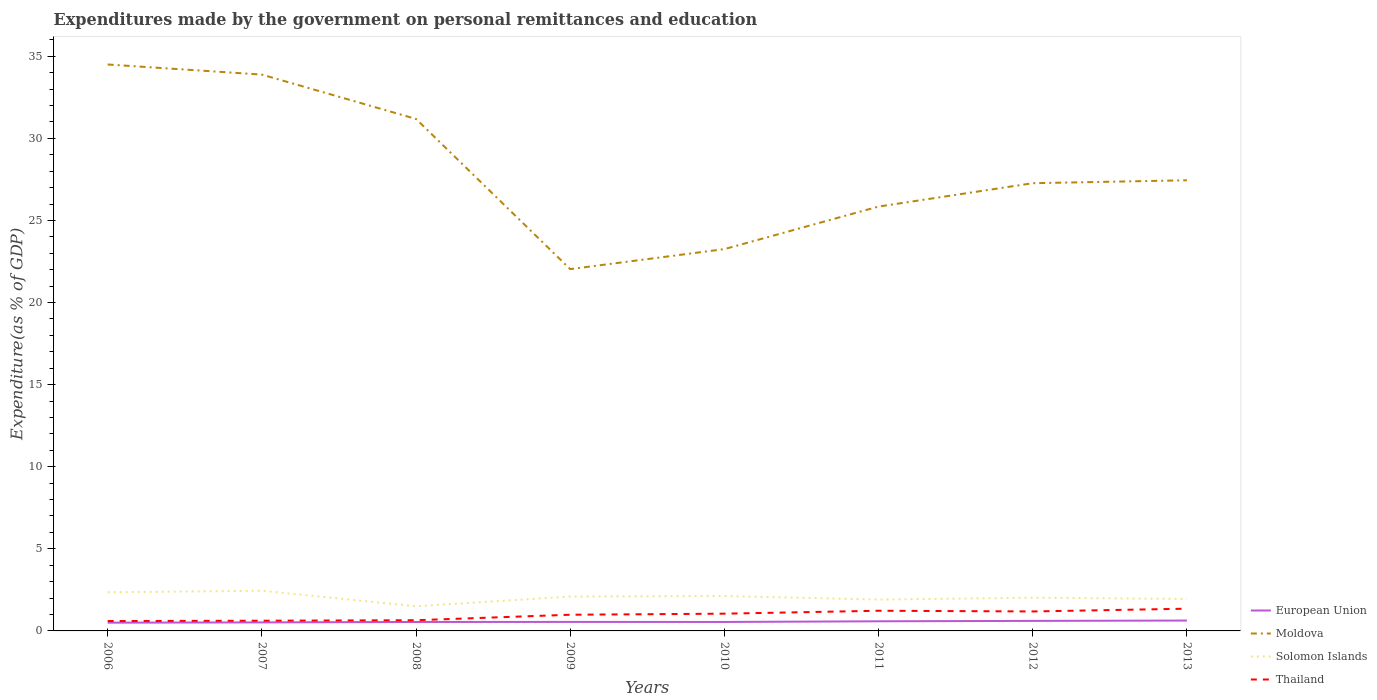Is the number of lines equal to the number of legend labels?
Keep it short and to the point. Yes. Across all years, what is the maximum expenditures made by the government on personal remittances and education in European Union?
Make the answer very short. 0.5. In which year was the expenditures made by the government on personal remittances and education in European Union maximum?
Your response must be concise. 2006. What is the total expenditures made by the government on personal remittances and education in Moldova in the graph?
Provide a short and direct response. 11.25. What is the difference between the highest and the second highest expenditures made by the government on personal remittances and education in Thailand?
Your answer should be very brief. 0.75. What is the difference between the highest and the lowest expenditures made by the government on personal remittances and education in Moldova?
Ensure brevity in your answer.  3. Is the expenditures made by the government on personal remittances and education in Thailand strictly greater than the expenditures made by the government on personal remittances and education in Moldova over the years?
Ensure brevity in your answer.  Yes. How many lines are there?
Provide a succinct answer. 4. How many years are there in the graph?
Offer a terse response. 8. What is the title of the graph?
Ensure brevity in your answer.  Expenditures made by the government on personal remittances and education. Does "Myanmar" appear as one of the legend labels in the graph?
Your response must be concise. No. What is the label or title of the Y-axis?
Offer a terse response. Expenditure(as % of GDP). What is the Expenditure(as % of GDP) in European Union in 2006?
Your response must be concise. 0.5. What is the Expenditure(as % of GDP) of Moldova in 2006?
Ensure brevity in your answer.  34.5. What is the Expenditure(as % of GDP) of Solomon Islands in 2006?
Ensure brevity in your answer.  2.35. What is the Expenditure(as % of GDP) in Thailand in 2006?
Make the answer very short. 0.6. What is the Expenditure(as % of GDP) of European Union in 2007?
Your answer should be compact. 0.52. What is the Expenditure(as % of GDP) of Moldova in 2007?
Provide a succinct answer. 33.88. What is the Expenditure(as % of GDP) in Solomon Islands in 2007?
Make the answer very short. 2.45. What is the Expenditure(as % of GDP) of Thailand in 2007?
Offer a very short reply. 0.62. What is the Expenditure(as % of GDP) in European Union in 2008?
Give a very brief answer. 0.55. What is the Expenditure(as % of GDP) in Moldova in 2008?
Make the answer very short. 31.18. What is the Expenditure(as % of GDP) of Solomon Islands in 2008?
Make the answer very short. 1.5. What is the Expenditure(as % of GDP) in Thailand in 2008?
Your answer should be very brief. 0.65. What is the Expenditure(as % of GDP) in European Union in 2009?
Offer a very short reply. 0.55. What is the Expenditure(as % of GDP) in Moldova in 2009?
Provide a succinct answer. 22.04. What is the Expenditure(as % of GDP) in Solomon Islands in 2009?
Provide a succinct answer. 2.09. What is the Expenditure(as % of GDP) in Thailand in 2009?
Provide a short and direct response. 0.99. What is the Expenditure(as % of GDP) in European Union in 2010?
Keep it short and to the point. 0.55. What is the Expenditure(as % of GDP) of Moldova in 2010?
Make the answer very short. 23.25. What is the Expenditure(as % of GDP) in Solomon Islands in 2010?
Offer a very short reply. 2.13. What is the Expenditure(as % of GDP) in Thailand in 2010?
Provide a short and direct response. 1.05. What is the Expenditure(as % of GDP) in European Union in 2011?
Keep it short and to the point. 0.59. What is the Expenditure(as % of GDP) in Moldova in 2011?
Provide a short and direct response. 25.85. What is the Expenditure(as % of GDP) of Solomon Islands in 2011?
Your response must be concise. 1.91. What is the Expenditure(as % of GDP) of Thailand in 2011?
Offer a very short reply. 1.23. What is the Expenditure(as % of GDP) in European Union in 2012?
Ensure brevity in your answer.  0.61. What is the Expenditure(as % of GDP) in Moldova in 2012?
Ensure brevity in your answer.  27.27. What is the Expenditure(as % of GDP) in Solomon Islands in 2012?
Offer a very short reply. 2.02. What is the Expenditure(as % of GDP) of Thailand in 2012?
Provide a succinct answer. 1.19. What is the Expenditure(as % of GDP) in European Union in 2013?
Your answer should be compact. 0.63. What is the Expenditure(as % of GDP) in Moldova in 2013?
Make the answer very short. 27.45. What is the Expenditure(as % of GDP) in Solomon Islands in 2013?
Provide a succinct answer. 1.95. What is the Expenditure(as % of GDP) in Thailand in 2013?
Provide a short and direct response. 1.35. Across all years, what is the maximum Expenditure(as % of GDP) of European Union?
Give a very brief answer. 0.63. Across all years, what is the maximum Expenditure(as % of GDP) of Moldova?
Provide a short and direct response. 34.5. Across all years, what is the maximum Expenditure(as % of GDP) in Solomon Islands?
Your answer should be very brief. 2.45. Across all years, what is the maximum Expenditure(as % of GDP) of Thailand?
Provide a short and direct response. 1.35. Across all years, what is the minimum Expenditure(as % of GDP) in European Union?
Provide a succinct answer. 0.5. Across all years, what is the minimum Expenditure(as % of GDP) in Moldova?
Keep it short and to the point. 22.04. Across all years, what is the minimum Expenditure(as % of GDP) of Solomon Islands?
Provide a short and direct response. 1.5. Across all years, what is the minimum Expenditure(as % of GDP) in Thailand?
Offer a very short reply. 0.6. What is the total Expenditure(as % of GDP) in European Union in the graph?
Offer a very short reply. 4.49. What is the total Expenditure(as % of GDP) in Moldova in the graph?
Offer a very short reply. 225.42. What is the total Expenditure(as % of GDP) in Solomon Islands in the graph?
Offer a terse response. 16.4. What is the total Expenditure(as % of GDP) in Thailand in the graph?
Give a very brief answer. 7.68. What is the difference between the Expenditure(as % of GDP) of European Union in 2006 and that in 2007?
Give a very brief answer. -0.02. What is the difference between the Expenditure(as % of GDP) in Moldova in 2006 and that in 2007?
Ensure brevity in your answer.  0.62. What is the difference between the Expenditure(as % of GDP) of Solomon Islands in 2006 and that in 2007?
Keep it short and to the point. -0.1. What is the difference between the Expenditure(as % of GDP) of Thailand in 2006 and that in 2007?
Ensure brevity in your answer.  -0.02. What is the difference between the Expenditure(as % of GDP) in European Union in 2006 and that in 2008?
Offer a terse response. -0.04. What is the difference between the Expenditure(as % of GDP) of Moldova in 2006 and that in 2008?
Your answer should be compact. 3.32. What is the difference between the Expenditure(as % of GDP) of Solomon Islands in 2006 and that in 2008?
Your answer should be very brief. 0.85. What is the difference between the Expenditure(as % of GDP) in Thailand in 2006 and that in 2008?
Your response must be concise. -0.05. What is the difference between the Expenditure(as % of GDP) in European Union in 2006 and that in 2009?
Give a very brief answer. -0.05. What is the difference between the Expenditure(as % of GDP) of Moldova in 2006 and that in 2009?
Provide a short and direct response. 12.46. What is the difference between the Expenditure(as % of GDP) of Solomon Islands in 2006 and that in 2009?
Ensure brevity in your answer.  0.26. What is the difference between the Expenditure(as % of GDP) of Thailand in 2006 and that in 2009?
Your answer should be compact. -0.38. What is the difference between the Expenditure(as % of GDP) of European Union in 2006 and that in 2010?
Ensure brevity in your answer.  -0.04. What is the difference between the Expenditure(as % of GDP) of Moldova in 2006 and that in 2010?
Your answer should be very brief. 11.24. What is the difference between the Expenditure(as % of GDP) in Solomon Islands in 2006 and that in 2010?
Offer a very short reply. 0.23. What is the difference between the Expenditure(as % of GDP) of Thailand in 2006 and that in 2010?
Give a very brief answer. -0.45. What is the difference between the Expenditure(as % of GDP) in European Union in 2006 and that in 2011?
Offer a terse response. -0.08. What is the difference between the Expenditure(as % of GDP) in Moldova in 2006 and that in 2011?
Provide a short and direct response. 8.65. What is the difference between the Expenditure(as % of GDP) of Solomon Islands in 2006 and that in 2011?
Ensure brevity in your answer.  0.44. What is the difference between the Expenditure(as % of GDP) of Thailand in 2006 and that in 2011?
Keep it short and to the point. -0.63. What is the difference between the Expenditure(as % of GDP) of European Union in 2006 and that in 2012?
Keep it short and to the point. -0.11. What is the difference between the Expenditure(as % of GDP) of Moldova in 2006 and that in 2012?
Keep it short and to the point. 7.23. What is the difference between the Expenditure(as % of GDP) of Solomon Islands in 2006 and that in 2012?
Provide a succinct answer. 0.33. What is the difference between the Expenditure(as % of GDP) in Thailand in 2006 and that in 2012?
Your response must be concise. -0.58. What is the difference between the Expenditure(as % of GDP) of European Union in 2006 and that in 2013?
Give a very brief answer. -0.13. What is the difference between the Expenditure(as % of GDP) of Moldova in 2006 and that in 2013?
Make the answer very short. 7.05. What is the difference between the Expenditure(as % of GDP) in Solomon Islands in 2006 and that in 2013?
Your answer should be compact. 0.4. What is the difference between the Expenditure(as % of GDP) of Thailand in 2006 and that in 2013?
Give a very brief answer. -0.75. What is the difference between the Expenditure(as % of GDP) of European Union in 2007 and that in 2008?
Offer a terse response. -0.03. What is the difference between the Expenditure(as % of GDP) in Moldova in 2007 and that in 2008?
Provide a short and direct response. 2.7. What is the difference between the Expenditure(as % of GDP) of Solomon Islands in 2007 and that in 2008?
Your answer should be compact. 0.95. What is the difference between the Expenditure(as % of GDP) of Thailand in 2007 and that in 2008?
Your answer should be compact. -0.03. What is the difference between the Expenditure(as % of GDP) of European Union in 2007 and that in 2009?
Give a very brief answer. -0.03. What is the difference between the Expenditure(as % of GDP) of Moldova in 2007 and that in 2009?
Your answer should be very brief. 11.85. What is the difference between the Expenditure(as % of GDP) of Solomon Islands in 2007 and that in 2009?
Your answer should be compact. 0.35. What is the difference between the Expenditure(as % of GDP) of Thailand in 2007 and that in 2009?
Provide a short and direct response. -0.36. What is the difference between the Expenditure(as % of GDP) in European Union in 2007 and that in 2010?
Your answer should be very brief. -0.03. What is the difference between the Expenditure(as % of GDP) of Moldova in 2007 and that in 2010?
Offer a terse response. 10.63. What is the difference between the Expenditure(as % of GDP) in Solomon Islands in 2007 and that in 2010?
Your answer should be compact. 0.32. What is the difference between the Expenditure(as % of GDP) in Thailand in 2007 and that in 2010?
Provide a short and direct response. -0.43. What is the difference between the Expenditure(as % of GDP) in European Union in 2007 and that in 2011?
Keep it short and to the point. -0.07. What is the difference between the Expenditure(as % of GDP) of Moldova in 2007 and that in 2011?
Offer a terse response. 8.04. What is the difference between the Expenditure(as % of GDP) of Solomon Islands in 2007 and that in 2011?
Make the answer very short. 0.54. What is the difference between the Expenditure(as % of GDP) in Thailand in 2007 and that in 2011?
Your answer should be compact. -0.61. What is the difference between the Expenditure(as % of GDP) in European Union in 2007 and that in 2012?
Offer a terse response. -0.09. What is the difference between the Expenditure(as % of GDP) of Moldova in 2007 and that in 2012?
Your answer should be compact. 6.61. What is the difference between the Expenditure(as % of GDP) in Solomon Islands in 2007 and that in 2012?
Your answer should be compact. 0.43. What is the difference between the Expenditure(as % of GDP) of Thailand in 2007 and that in 2012?
Offer a very short reply. -0.56. What is the difference between the Expenditure(as % of GDP) of European Union in 2007 and that in 2013?
Keep it short and to the point. -0.11. What is the difference between the Expenditure(as % of GDP) of Moldova in 2007 and that in 2013?
Ensure brevity in your answer.  6.44. What is the difference between the Expenditure(as % of GDP) of Solomon Islands in 2007 and that in 2013?
Provide a short and direct response. 0.5. What is the difference between the Expenditure(as % of GDP) in Thailand in 2007 and that in 2013?
Provide a short and direct response. -0.73. What is the difference between the Expenditure(as % of GDP) in European Union in 2008 and that in 2009?
Make the answer very short. -0. What is the difference between the Expenditure(as % of GDP) in Moldova in 2008 and that in 2009?
Your answer should be compact. 9.15. What is the difference between the Expenditure(as % of GDP) of Solomon Islands in 2008 and that in 2009?
Offer a very short reply. -0.59. What is the difference between the Expenditure(as % of GDP) of Thailand in 2008 and that in 2009?
Keep it short and to the point. -0.33. What is the difference between the Expenditure(as % of GDP) of European Union in 2008 and that in 2010?
Give a very brief answer. -0. What is the difference between the Expenditure(as % of GDP) of Moldova in 2008 and that in 2010?
Provide a short and direct response. 7.93. What is the difference between the Expenditure(as % of GDP) of Solomon Islands in 2008 and that in 2010?
Your response must be concise. -0.62. What is the difference between the Expenditure(as % of GDP) in Thailand in 2008 and that in 2010?
Give a very brief answer. -0.4. What is the difference between the Expenditure(as % of GDP) in European Union in 2008 and that in 2011?
Provide a succinct answer. -0.04. What is the difference between the Expenditure(as % of GDP) of Moldova in 2008 and that in 2011?
Your answer should be very brief. 5.34. What is the difference between the Expenditure(as % of GDP) in Solomon Islands in 2008 and that in 2011?
Your answer should be very brief. -0.41. What is the difference between the Expenditure(as % of GDP) in Thailand in 2008 and that in 2011?
Give a very brief answer. -0.58. What is the difference between the Expenditure(as % of GDP) in European Union in 2008 and that in 2012?
Offer a very short reply. -0.07. What is the difference between the Expenditure(as % of GDP) of Moldova in 2008 and that in 2012?
Offer a very short reply. 3.91. What is the difference between the Expenditure(as % of GDP) of Solomon Islands in 2008 and that in 2012?
Provide a succinct answer. -0.52. What is the difference between the Expenditure(as % of GDP) of Thailand in 2008 and that in 2012?
Offer a terse response. -0.53. What is the difference between the Expenditure(as % of GDP) in European Union in 2008 and that in 2013?
Your answer should be compact. -0.09. What is the difference between the Expenditure(as % of GDP) in Moldova in 2008 and that in 2013?
Offer a terse response. 3.74. What is the difference between the Expenditure(as % of GDP) of Solomon Islands in 2008 and that in 2013?
Your answer should be compact. -0.44. What is the difference between the Expenditure(as % of GDP) in Thailand in 2008 and that in 2013?
Your answer should be compact. -0.7. What is the difference between the Expenditure(as % of GDP) of European Union in 2009 and that in 2010?
Your response must be concise. 0. What is the difference between the Expenditure(as % of GDP) in Moldova in 2009 and that in 2010?
Your response must be concise. -1.22. What is the difference between the Expenditure(as % of GDP) of Solomon Islands in 2009 and that in 2010?
Your answer should be very brief. -0.03. What is the difference between the Expenditure(as % of GDP) in Thailand in 2009 and that in 2010?
Offer a terse response. -0.06. What is the difference between the Expenditure(as % of GDP) of European Union in 2009 and that in 2011?
Offer a very short reply. -0.04. What is the difference between the Expenditure(as % of GDP) of Moldova in 2009 and that in 2011?
Offer a terse response. -3.81. What is the difference between the Expenditure(as % of GDP) in Solomon Islands in 2009 and that in 2011?
Provide a short and direct response. 0.18. What is the difference between the Expenditure(as % of GDP) in Thailand in 2009 and that in 2011?
Your answer should be compact. -0.24. What is the difference between the Expenditure(as % of GDP) in European Union in 2009 and that in 2012?
Ensure brevity in your answer.  -0.06. What is the difference between the Expenditure(as % of GDP) of Moldova in 2009 and that in 2012?
Keep it short and to the point. -5.23. What is the difference between the Expenditure(as % of GDP) in Solomon Islands in 2009 and that in 2012?
Offer a very short reply. 0.07. What is the difference between the Expenditure(as % of GDP) in Thailand in 2009 and that in 2012?
Provide a short and direct response. -0.2. What is the difference between the Expenditure(as % of GDP) of European Union in 2009 and that in 2013?
Offer a very short reply. -0.08. What is the difference between the Expenditure(as % of GDP) in Moldova in 2009 and that in 2013?
Your answer should be very brief. -5.41. What is the difference between the Expenditure(as % of GDP) in Solomon Islands in 2009 and that in 2013?
Offer a very short reply. 0.15. What is the difference between the Expenditure(as % of GDP) in Thailand in 2009 and that in 2013?
Offer a terse response. -0.37. What is the difference between the Expenditure(as % of GDP) of European Union in 2010 and that in 2011?
Your answer should be compact. -0.04. What is the difference between the Expenditure(as % of GDP) in Moldova in 2010 and that in 2011?
Provide a succinct answer. -2.59. What is the difference between the Expenditure(as % of GDP) of Solomon Islands in 2010 and that in 2011?
Provide a succinct answer. 0.22. What is the difference between the Expenditure(as % of GDP) in Thailand in 2010 and that in 2011?
Offer a very short reply. -0.18. What is the difference between the Expenditure(as % of GDP) in European Union in 2010 and that in 2012?
Make the answer very short. -0.07. What is the difference between the Expenditure(as % of GDP) of Moldova in 2010 and that in 2012?
Offer a terse response. -4.01. What is the difference between the Expenditure(as % of GDP) of Solomon Islands in 2010 and that in 2012?
Keep it short and to the point. 0.1. What is the difference between the Expenditure(as % of GDP) in Thailand in 2010 and that in 2012?
Provide a short and direct response. -0.14. What is the difference between the Expenditure(as % of GDP) in European Union in 2010 and that in 2013?
Make the answer very short. -0.09. What is the difference between the Expenditure(as % of GDP) of Moldova in 2010 and that in 2013?
Keep it short and to the point. -4.19. What is the difference between the Expenditure(as % of GDP) in Solomon Islands in 2010 and that in 2013?
Your response must be concise. 0.18. What is the difference between the Expenditure(as % of GDP) in Thailand in 2010 and that in 2013?
Your answer should be compact. -0.3. What is the difference between the Expenditure(as % of GDP) in European Union in 2011 and that in 2012?
Provide a short and direct response. -0.02. What is the difference between the Expenditure(as % of GDP) of Moldova in 2011 and that in 2012?
Keep it short and to the point. -1.42. What is the difference between the Expenditure(as % of GDP) of Solomon Islands in 2011 and that in 2012?
Ensure brevity in your answer.  -0.11. What is the difference between the Expenditure(as % of GDP) in Thailand in 2011 and that in 2012?
Your answer should be very brief. 0.04. What is the difference between the Expenditure(as % of GDP) of European Union in 2011 and that in 2013?
Offer a very short reply. -0.05. What is the difference between the Expenditure(as % of GDP) in Moldova in 2011 and that in 2013?
Give a very brief answer. -1.6. What is the difference between the Expenditure(as % of GDP) of Solomon Islands in 2011 and that in 2013?
Offer a very short reply. -0.04. What is the difference between the Expenditure(as % of GDP) of Thailand in 2011 and that in 2013?
Provide a succinct answer. -0.13. What is the difference between the Expenditure(as % of GDP) of European Union in 2012 and that in 2013?
Offer a very short reply. -0.02. What is the difference between the Expenditure(as % of GDP) in Moldova in 2012 and that in 2013?
Your answer should be very brief. -0.18. What is the difference between the Expenditure(as % of GDP) of Solomon Islands in 2012 and that in 2013?
Your answer should be very brief. 0.07. What is the difference between the Expenditure(as % of GDP) of Thailand in 2012 and that in 2013?
Provide a succinct answer. -0.17. What is the difference between the Expenditure(as % of GDP) of European Union in 2006 and the Expenditure(as % of GDP) of Moldova in 2007?
Offer a very short reply. -33.38. What is the difference between the Expenditure(as % of GDP) of European Union in 2006 and the Expenditure(as % of GDP) of Solomon Islands in 2007?
Your answer should be compact. -1.95. What is the difference between the Expenditure(as % of GDP) of European Union in 2006 and the Expenditure(as % of GDP) of Thailand in 2007?
Offer a very short reply. -0.12. What is the difference between the Expenditure(as % of GDP) of Moldova in 2006 and the Expenditure(as % of GDP) of Solomon Islands in 2007?
Keep it short and to the point. 32.05. What is the difference between the Expenditure(as % of GDP) in Moldova in 2006 and the Expenditure(as % of GDP) in Thailand in 2007?
Your answer should be compact. 33.88. What is the difference between the Expenditure(as % of GDP) in Solomon Islands in 2006 and the Expenditure(as % of GDP) in Thailand in 2007?
Ensure brevity in your answer.  1.73. What is the difference between the Expenditure(as % of GDP) of European Union in 2006 and the Expenditure(as % of GDP) of Moldova in 2008?
Provide a succinct answer. -30.68. What is the difference between the Expenditure(as % of GDP) of European Union in 2006 and the Expenditure(as % of GDP) of Solomon Islands in 2008?
Your response must be concise. -1. What is the difference between the Expenditure(as % of GDP) of European Union in 2006 and the Expenditure(as % of GDP) of Thailand in 2008?
Keep it short and to the point. -0.15. What is the difference between the Expenditure(as % of GDP) of Moldova in 2006 and the Expenditure(as % of GDP) of Solomon Islands in 2008?
Provide a succinct answer. 33. What is the difference between the Expenditure(as % of GDP) in Moldova in 2006 and the Expenditure(as % of GDP) in Thailand in 2008?
Provide a succinct answer. 33.85. What is the difference between the Expenditure(as % of GDP) in Solomon Islands in 2006 and the Expenditure(as % of GDP) in Thailand in 2008?
Provide a succinct answer. 1.7. What is the difference between the Expenditure(as % of GDP) in European Union in 2006 and the Expenditure(as % of GDP) in Moldova in 2009?
Provide a short and direct response. -21.53. What is the difference between the Expenditure(as % of GDP) of European Union in 2006 and the Expenditure(as % of GDP) of Solomon Islands in 2009?
Keep it short and to the point. -1.59. What is the difference between the Expenditure(as % of GDP) in European Union in 2006 and the Expenditure(as % of GDP) in Thailand in 2009?
Ensure brevity in your answer.  -0.48. What is the difference between the Expenditure(as % of GDP) of Moldova in 2006 and the Expenditure(as % of GDP) of Solomon Islands in 2009?
Provide a short and direct response. 32.41. What is the difference between the Expenditure(as % of GDP) of Moldova in 2006 and the Expenditure(as % of GDP) of Thailand in 2009?
Offer a terse response. 33.51. What is the difference between the Expenditure(as % of GDP) of Solomon Islands in 2006 and the Expenditure(as % of GDP) of Thailand in 2009?
Your answer should be very brief. 1.37. What is the difference between the Expenditure(as % of GDP) in European Union in 2006 and the Expenditure(as % of GDP) in Moldova in 2010?
Keep it short and to the point. -22.75. What is the difference between the Expenditure(as % of GDP) of European Union in 2006 and the Expenditure(as % of GDP) of Solomon Islands in 2010?
Your response must be concise. -1.62. What is the difference between the Expenditure(as % of GDP) of European Union in 2006 and the Expenditure(as % of GDP) of Thailand in 2010?
Provide a short and direct response. -0.55. What is the difference between the Expenditure(as % of GDP) in Moldova in 2006 and the Expenditure(as % of GDP) in Solomon Islands in 2010?
Make the answer very short. 32.37. What is the difference between the Expenditure(as % of GDP) of Moldova in 2006 and the Expenditure(as % of GDP) of Thailand in 2010?
Provide a short and direct response. 33.45. What is the difference between the Expenditure(as % of GDP) in Solomon Islands in 2006 and the Expenditure(as % of GDP) in Thailand in 2010?
Make the answer very short. 1.3. What is the difference between the Expenditure(as % of GDP) of European Union in 2006 and the Expenditure(as % of GDP) of Moldova in 2011?
Give a very brief answer. -25.34. What is the difference between the Expenditure(as % of GDP) in European Union in 2006 and the Expenditure(as % of GDP) in Solomon Islands in 2011?
Give a very brief answer. -1.41. What is the difference between the Expenditure(as % of GDP) of European Union in 2006 and the Expenditure(as % of GDP) of Thailand in 2011?
Provide a short and direct response. -0.73. What is the difference between the Expenditure(as % of GDP) of Moldova in 2006 and the Expenditure(as % of GDP) of Solomon Islands in 2011?
Keep it short and to the point. 32.59. What is the difference between the Expenditure(as % of GDP) in Moldova in 2006 and the Expenditure(as % of GDP) in Thailand in 2011?
Keep it short and to the point. 33.27. What is the difference between the Expenditure(as % of GDP) in Solomon Islands in 2006 and the Expenditure(as % of GDP) in Thailand in 2011?
Give a very brief answer. 1.12. What is the difference between the Expenditure(as % of GDP) of European Union in 2006 and the Expenditure(as % of GDP) of Moldova in 2012?
Keep it short and to the point. -26.77. What is the difference between the Expenditure(as % of GDP) in European Union in 2006 and the Expenditure(as % of GDP) in Solomon Islands in 2012?
Your response must be concise. -1.52. What is the difference between the Expenditure(as % of GDP) of European Union in 2006 and the Expenditure(as % of GDP) of Thailand in 2012?
Your response must be concise. -0.68. What is the difference between the Expenditure(as % of GDP) in Moldova in 2006 and the Expenditure(as % of GDP) in Solomon Islands in 2012?
Give a very brief answer. 32.48. What is the difference between the Expenditure(as % of GDP) in Moldova in 2006 and the Expenditure(as % of GDP) in Thailand in 2012?
Keep it short and to the point. 33.31. What is the difference between the Expenditure(as % of GDP) in Solomon Islands in 2006 and the Expenditure(as % of GDP) in Thailand in 2012?
Your answer should be compact. 1.17. What is the difference between the Expenditure(as % of GDP) of European Union in 2006 and the Expenditure(as % of GDP) of Moldova in 2013?
Provide a short and direct response. -26.94. What is the difference between the Expenditure(as % of GDP) in European Union in 2006 and the Expenditure(as % of GDP) in Solomon Islands in 2013?
Ensure brevity in your answer.  -1.45. What is the difference between the Expenditure(as % of GDP) of European Union in 2006 and the Expenditure(as % of GDP) of Thailand in 2013?
Make the answer very short. -0.85. What is the difference between the Expenditure(as % of GDP) in Moldova in 2006 and the Expenditure(as % of GDP) in Solomon Islands in 2013?
Provide a short and direct response. 32.55. What is the difference between the Expenditure(as % of GDP) of Moldova in 2006 and the Expenditure(as % of GDP) of Thailand in 2013?
Ensure brevity in your answer.  33.14. What is the difference between the Expenditure(as % of GDP) in Solomon Islands in 2006 and the Expenditure(as % of GDP) in Thailand in 2013?
Provide a short and direct response. 1. What is the difference between the Expenditure(as % of GDP) of European Union in 2007 and the Expenditure(as % of GDP) of Moldova in 2008?
Offer a terse response. -30.66. What is the difference between the Expenditure(as % of GDP) in European Union in 2007 and the Expenditure(as % of GDP) in Solomon Islands in 2008?
Make the answer very short. -0.98. What is the difference between the Expenditure(as % of GDP) of European Union in 2007 and the Expenditure(as % of GDP) of Thailand in 2008?
Offer a very short reply. -0.13. What is the difference between the Expenditure(as % of GDP) of Moldova in 2007 and the Expenditure(as % of GDP) of Solomon Islands in 2008?
Make the answer very short. 32.38. What is the difference between the Expenditure(as % of GDP) in Moldova in 2007 and the Expenditure(as % of GDP) in Thailand in 2008?
Provide a short and direct response. 33.23. What is the difference between the Expenditure(as % of GDP) of Solomon Islands in 2007 and the Expenditure(as % of GDP) of Thailand in 2008?
Your response must be concise. 1.8. What is the difference between the Expenditure(as % of GDP) of European Union in 2007 and the Expenditure(as % of GDP) of Moldova in 2009?
Offer a terse response. -21.52. What is the difference between the Expenditure(as % of GDP) in European Union in 2007 and the Expenditure(as % of GDP) in Solomon Islands in 2009?
Provide a succinct answer. -1.58. What is the difference between the Expenditure(as % of GDP) in European Union in 2007 and the Expenditure(as % of GDP) in Thailand in 2009?
Your answer should be compact. -0.47. What is the difference between the Expenditure(as % of GDP) in Moldova in 2007 and the Expenditure(as % of GDP) in Solomon Islands in 2009?
Ensure brevity in your answer.  31.79. What is the difference between the Expenditure(as % of GDP) in Moldova in 2007 and the Expenditure(as % of GDP) in Thailand in 2009?
Ensure brevity in your answer.  32.9. What is the difference between the Expenditure(as % of GDP) in Solomon Islands in 2007 and the Expenditure(as % of GDP) in Thailand in 2009?
Your answer should be compact. 1.46. What is the difference between the Expenditure(as % of GDP) of European Union in 2007 and the Expenditure(as % of GDP) of Moldova in 2010?
Offer a very short reply. -22.74. What is the difference between the Expenditure(as % of GDP) of European Union in 2007 and the Expenditure(as % of GDP) of Solomon Islands in 2010?
Give a very brief answer. -1.61. What is the difference between the Expenditure(as % of GDP) of European Union in 2007 and the Expenditure(as % of GDP) of Thailand in 2010?
Your answer should be very brief. -0.53. What is the difference between the Expenditure(as % of GDP) in Moldova in 2007 and the Expenditure(as % of GDP) in Solomon Islands in 2010?
Provide a short and direct response. 31.76. What is the difference between the Expenditure(as % of GDP) of Moldova in 2007 and the Expenditure(as % of GDP) of Thailand in 2010?
Your response must be concise. 32.83. What is the difference between the Expenditure(as % of GDP) in Solomon Islands in 2007 and the Expenditure(as % of GDP) in Thailand in 2010?
Your response must be concise. 1.4. What is the difference between the Expenditure(as % of GDP) in European Union in 2007 and the Expenditure(as % of GDP) in Moldova in 2011?
Your response must be concise. -25.33. What is the difference between the Expenditure(as % of GDP) of European Union in 2007 and the Expenditure(as % of GDP) of Solomon Islands in 2011?
Provide a short and direct response. -1.39. What is the difference between the Expenditure(as % of GDP) of European Union in 2007 and the Expenditure(as % of GDP) of Thailand in 2011?
Your response must be concise. -0.71. What is the difference between the Expenditure(as % of GDP) in Moldova in 2007 and the Expenditure(as % of GDP) in Solomon Islands in 2011?
Keep it short and to the point. 31.97. What is the difference between the Expenditure(as % of GDP) of Moldova in 2007 and the Expenditure(as % of GDP) of Thailand in 2011?
Offer a terse response. 32.65. What is the difference between the Expenditure(as % of GDP) of Solomon Islands in 2007 and the Expenditure(as % of GDP) of Thailand in 2011?
Make the answer very short. 1.22. What is the difference between the Expenditure(as % of GDP) of European Union in 2007 and the Expenditure(as % of GDP) of Moldova in 2012?
Your answer should be compact. -26.75. What is the difference between the Expenditure(as % of GDP) of European Union in 2007 and the Expenditure(as % of GDP) of Solomon Islands in 2012?
Your response must be concise. -1.5. What is the difference between the Expenditure(as % of GDP) in European Union in 2007 and the Expenditure(as % of GDP) in Thailand in 2012?
Provide a succinct answer. -0.67. What is the difference between the Expenditure(as % of GDP) in Moldova in 2007 and the Expenditure(as % of GDP) in Solomon Islands in 2012?
Your response must be concise. 31.86. What is the difference between the Expenditure(as % of GDP) in Moldova in 2007 and the Expenditure(as % of GDP) in Thailand in 2012?
Provide a short and direct response. 32.7. What is the difference between the Expenditure(as % of GDP) in Solomon Islands in 2007 and the Expenditure(as % of GDP) in Thailand in 2012?
Offer a terse response. 1.26. What is the difference between the Expenditure(as % of GDP) in European Union in 2007 and the Expenditure(as % of GDP) in Moldova in 2013?
Make the answer very short. -26.93. What is the difference between the Expenditure(as % of GDP) of European Union in 2007 and the Expenditure(as % of GDP) of Solomon Islands in 2013?
Offer a very short reply. -1.43. What is the difference between the Expenditure(as % of GDP) in European Union in 2007 and the Expenditure(as % of GDP) in Thailand in 2013?
Offer a terse response. -0.84. What is the difference between the Expenditure(as % of GDP) in Moldova in 2007 and the Expenditure(as % of GDP) in Solomon Islands in 2013?
Your response must be concise. 31.94. What is the difference between the Expenditure(as % of GDP) of Moldova in 2007 and the Expenditure(as % of GDP) of Thailand in 2013?
Give a very brief answer. 32.53. What is the difference between the Expenditure(as % of GDP) in Solomon Islands in 2007 and the Expenditure(as % of GDP) in Thailand in 2013?
Your answer should be very brief. 1.09. What is the difference between the Expenditure(as % of GDP) in European Union in 2008 and the Expenditure(as % of GDP) in Moldova in 2009?
Your answer should be compact. -21.49. What is the difference between the Expenditure(as % of GDP) of European Union in 2008 and the Expenditure(as % of GDP) of Solomon Islands in 2009?
Your answer should be compact. -1.55. What is the difference between the Expenditure(as % of GDP) of European Union in 2008 and the Expenditure(as % of GDP) of Thailand in 2009?
Your response must be concise. -0.44. What is the difference between the Expenditure(as % of GDP) of Moldova in 2008 and the Expenditure(as % of GDP) of Solomon Islands in 2009?
Your response must be concise. 29.09. What is the difference between the Expenditure(as % of GDP) of Moldova in 2008 and the Expenditure(as % of GDP) of Thailand in 2009?
Provide a short and direct response. 30.2. What is the difference between the Expenditure(as % of GDP) in Solomon Islands in 2008 and the Expenditure(as % of GDP) in Thailand in 2009?
Your response must be concise. 0.52. What is the difference between the Expenditure(as % of GDP) in European Union in 2008 and the Expenditure(as % of GDP) in Moldova in 2010?
Give a very brief answer. -22.71. What is the difference between the Expenditure(as % of GDP) of European Union in 2008 and the Expenditure(as % of GDP) of Solomon Islands in 2010?
Offer a terse response. -1.58. What is the difference between the Expenditure(as % of GDP) in European Union in 2008 and the Expenditure(as % of GDP) in Thailand in 2010?
Make the answer very short. -0.5. What is the difference between the Expenditure(as % of GDP) of Moldova in 2008 and the Expenditure(as % of GDP) of Solomon Islands in 2010?
Offer a very short reply. 29.06. What is the difference between the Expenditure(as % of GDP) in Moldova in 2008 and the Expenditure(as % of GDP) in Thailand in 2010?
Offer a terse response. 30.13. What is the difference between the Expenditure(as % of GDP) of Solomon Islands in 2008 and the Expenditure(as % of GDP) of Thailand in 2010?
Ensure brevity in your answer.  0.45. What is the difference between the Expenditure(as % of GDP) in European Union in 2008 and the Expenditure(as % of GDP) in Moldova in 2011?
Make the answer very short. -25.3. What is the difference between the Expenditure(as % of GDP) of European Union in 2008 and the Expenditure(as % of GDP) of Solomon Islands in 2011?
Keep it short and to the point. -1.36. What is the difference between the Expenditure(as % of GDP) in European Union in 2008 and the Expenditure(as % of GDP) in Thailand in 2011?
Offer a terse response. -0.68. What is the difference between the Expenditure(as % of GDP) of Moldova in 2008 and the Expenditure(as % of GDP) of Solomon Islands in 2011?
Provide a short and direct response. 29.27. What is the difference between the Expenditure(as % of GDP) in Moldova in 2008 and the Expenditure(as % of GDP) in Thailand in 2011?
Your response must be concise. 29.95. What is the difference between the Expenditure(as % of GDP) of Solomon Islands in 2008 and the Expenditure(as % of GDP) of Thailand in 2011?
Keep it short and to the point. 0.27. What is the difference between the Expenditure(as % of GDP) of European Union in 2008 and the Expenditure(as % of GDP) of Moldova in 2012?
Offer a terse response. -26.72. What is the difference between the Expenditure(as % of GDP) of European Union in 2008 and the Expenditure(as % of GDP) of Solomon Islands in 2012?
Your answer should be compact. -1.48. What is the difference between the Expenditure(as % of GDP) of European Union in 2008 and the Expenditure(as % of GDP) of Thailand in 2012?
Offer a very short reply. -0.64. What is the difference between the Expenditure(as % of GDP) of Moldova in 2008 and the Expenditure(as % of GDP) of Solomon Islands in 2012?
Give a very brief answer. 29.16. What is the difference between the Expenditure(as % of GDP) in Moldova in 2008 and the Expenditure(as % of GDP) in Thailand in 2012?
Provide a succinct answer. 30. What is the difference between the Expenditure(as % of GDP) of Solomon Islands in 2008 and the Expenditure(as % of GDP) of Thailand in 2012?
Ensure brevity in your answer.  0.32. What is the difference between the Expenditure(as % of GDP) in European Union in 2008 and the Expenditure(as % of GDP) in Moldova in 2013?
Make the answer very short. -26.9. What is the difference between the Expenditure(as % of GDP) of European Union in 2008 and the Expenditure(as % of GDP) of Solomon Islands in 2013?
Your response must be concise. -1.4. What is the difference between the Expenditure(as % of GDP) in European Union in 2008 and the Expenditure(as % of GDP) in Thailand in 2013?
Your response must be concise. -0.81. What is the difference between the Expenditure(as % of GDP) of Moldova in 2008 and the Expenditure(as % of GDP) of Solomon Islands in 2013?
Your answer should be compact. 29.23. What is the difference between the Expenditure(as % of GDP) in Moldova in 2008 and the Expenditure(as % of GDP) in Thailand in 2013?
Your answer should be compact. 29.83. What is the difference between the Expenditure(as % of GDP) of Solomon Islands in 2008 and the Expenditure(as % of GDP) of Thailand in 2013?
Give a very brief answer. 0.15. What is the difference between the Expenditure(as % of GDP) in European Union in 2009 and the Expenditure(as % of GDP) in Moldova in 2010?
Provide a succinct answer. -22.71. What is the difference between the Expenditure(as % of GDP) in European Union in 2009 and the Expenditure(as % of GDP) in Solomon Islands in 2010?
Your answer should be compact. -1.58. What is the difference between the Expenditure(as % of GDP) in European Union in 2009 and the Expenditure(as % of GDP) in Thailand in 2010?
Give a very brief answer. -0.5. What is the difference between the Expenditure(as % of GDP) of Moldova in 2009 and the Expenditure(as % of GDP) of Solomon Islands in 2010?
Provide a short and direct response. 19.91. What is the difference between the Expenditure(as % of GDP) in Moldova in 2009 and the Expenditure(as % of GDP) in Thailand in 2010?
Your answer should be very brief. 20.99. What is the difference between the Expenditure(as % of GDP) in Solomon Islands in 2009 and the Expenditure(as % of GDP) in Thailand in 2010?
Provide a succinct answer. 1.04. What is the difference between the Expenditure(as % of GDP) in European Union in 2009 and the Expenditure(as % of GDP) in Moldova in 2011?
Offer a very short reply. -25.3. What is the difference between the Expenditure(as % of GDP) in European Union in 2009 and the Expenditure(as % of GDP) in Solomon Islands in 2011?
Keep it short and to the point. -1.36. What is the difference between the Expenditure(as % of GDP) of European Union in 2009 and the Expenditure(as % of GDP) of Thailand in 2011?
Your answer should be compact. -0.68. What is the difference between the Expenditure(as % of GDP) in Moldova in 2009 and the Expenditure(as % of GDP) in Solomon Islands in 2011?
Keep it short and to the point. 20.13. What is the difference between the Expenditure(as % of GDP) of Moldova in 2009 and the Expenditure(as % of GDP) of Thailand in 2011?
Your answer should be very brief. 20.81. What is the difference between the Expenditure(as % of GDP) in Solomon Islands in 2009 and the Expenditure(as % of GDP) in Thailand in 2011?
Your response must be concise. 0.86. What is the difference between the Expenditure(as % of GDP) in European Union in 2009 and the Expenditure(as % of GDP) in Moldova in 2012?
Ensure brevity in your answer.  -26.72. What is the difference between the Expenditure(as % of GDP) of European Union in 2009 and the Expenditure(as % of GDP) of Solomon Islands in 2012?
Keep it short and to the point. -1.47. What is the difference between the Expenditure(as % of GDP) of European Union in 2009 and the Expenditure(as % of GDP) of Thailand in 2012?
Your answer should be compact. -0.64. What is the difference between the Expenditure(as % of GDP) in Moldova in 2009 and the Expenditure(as % of GDP) in Solomon Islands in 2012?
Your answer should be compact. 20.01. What is the difference between the Expenditure(as % of GDP) in Moldova in 2009 and the Expenditure(as % of GDP) in Thailand in 2012?
Provide a short and direct response. 20.85. What is the difference between the Expenditure(as % of GDP) in Solomon Islands in 2009 and the Expenditure(as % of GDP) in Thailand in 2012?
Your answer should be very brief. 0.91. What is the difference between the Expenditure(as % of GDP) in European Union in 2009 and the Expenditure(as % of GDP) in Moldova in 2013?
Ensure brevity in your answer.  -26.9. What is the difference between the Expenditure(as % of GDP) of European Union in 2009 and the Expenditure(as % of GDP) of Solomon Islands in 2013?
Your response must be concise. -1.4. What is the difference between the Expenditure(as % of GDP) of European Union in 2009 and the Expenditure(as % of GDP) of Thailand in 2013?
Your answer should be very brief. -0.81. What is the difference between the Expenditure(as % of GDP) of Moldova in 2009 and the Expenditure(as % of GDP) of Solomon Islands in 2013?
Keep it short and to the point. 20.09. What is the difference between the Expenditure(as % of GDP) of Moldova in 2009 and the Expenditure(as % of GDP) of Thailand in 2013?
Your answer should be compact. 20.68. What is the difference between the Expenditure(as % of GDP) of Solomon Islands in 2009 and the Expenditure(as % of GDP) of Thailand in 2013?
Offer a very short reply. 0.74. What is the difference between the Expenditure(as % of GDP) in European Union in 2010 and the Expenditure(as % of GDP) in Moldova in 2011?
Your response must be concise. -25.3. What is the difference between the Expenditure(as % of GDP) of European Union in 2010 and the Expenditure(as % of GDP) of Solomon Islands in 2011?
Your answer should be very brief. -1.36. What is the difference between the Expenditure(as % of GDP) in European Union in 2010 and the Expenditure(as % of GDP) in Thailand in 2011?
Offer a very short reply. -0.68. What is the difference between the Expenditure(as % of GDP) in Moldova in 2010 and the Expenditure(as % of GDP) in Solomon Islands in 2011?
Provide a succinct answer. 21.34. What is the difference between the Expenditure(as % of GDP) in Moldova in 2010 and the Expenditure(as % of GDP) in Thailand in 2011?
Offer a very short reply. 22.03. What is the difference between the Expenditure(as % of GDP) of Solomon Islands in 2010 and the Expenditure(as % of GDP) of Thailand in 2011?
Your answer should be compact. 0.9. What is the difference between the Expenditure(as % of GDP) of European Union in 2010 and the Expenditure(as % of GDP) of Moldova in 2012?
Keep it short and to the point. -26.72. What is the difference between the Expenditure(as % of GDP) in European Union in 2010 and the Expenditure(as % of GDP) in Solomon Islands in 2012?
Your answer should be compact. -1.48. What is the difference between the Expenditure(as % of GDP) of European Union in 2010 and the Expenditure(as % of GDP) of Thailand in 2012?
Keep it short and to the point. -0.64. What is the difference between the Expenditure(as % of GDP) of Moldova in 2010 and the Expenditure(as % of GDP) of Solomon Islands in 2012?
Give a very brief answer. 21.23. What is the difference between the Expenditure(as % of GDP) of Moldova in 2010 and the Expenditure(as % of GDP) of Thailand in 2012?
Provide a short and direct response. 22.07. What is the difference between the Expenditure(as % of GDP) in Solomon Islands in 2010 and the Expenditure(as % of GDP) in Thailand in 2012?
Provide a short and direct response. 0.94. What is the difference between the Expenditure(as % of GDP) of European Union in 2010 and the Expenditure(as % of GDP) of Moldova in 2013?
Your answer should be very brief. -26.9. What is the difference between the Expenditure(as % of GDP) of European Union in 2010 and the Expenditure(as % of GDP) of Solomon Islands in 2013?
Provide a short and direct response. -1.4. What is the difference between the Expenditure(as % of GDP) in European Union in 2010 and the Expenditure(as % of GDP) in Thailand in 2013?
Provide a succinct answer. -0.81. What is the difference between the Expenditure(as % of GDP) of Moldova in 2010 and the Expenditure(as % of GDP) of Solomon Islands in 2013?
Keep it short and to the point. 21.31. What is the difference between the Expenditure(as % of GDP) in Moldova in 2010 and the Expenditure(as % of GDP) in Thailand in 2013?
Provide a succinct answer. 21.9. What is the difference between the Expenditure(as % of GDP) of Solomon Islands in 2010 and the Expenditure(as % of GDP) of Thailand in 2013?
Your answer should be compact. 0.77. What is the difference between the Expenditure(as % of GDP) of European Union in 2011 and the Expenditure(as % of GDP) of Moldova in 2012?
Offer a terse response. -26.68. What is the difference between the Expenditure(as % of GDP) of European Union in 2011 and the Expenditure(as % of GDP) of Solomon Islands in 2012?
Ensure brevity in your answer.  -1.43. What is the difference between the Expenditure(as % of GDP) of European Union in 2011 and the Expenditure(as % of GDP) of Thailand in 2012?
Offer a very short reply. -0.6. What is the difference between the Expenditure(as % of GDP) in Moldova in 2011 and the Expenditure(as % of GDP) in Solomon Islands in 2012?
Your answer should be very brief. 23.82. What is the difference between the Expenditure(as % of GDP) of Moldova in 2011 and the Expenditure(as % of GDP) of Thailand in 2012?
Provide a short and direct response. 24.66. What is the difference between the Expenditure(as % of GDP) of Solomon Islands in 2011 and the Expenditure(as % of GDP) of Thailand in 2012?
Give a very brief answer. 0.72. What is the difference between the Expenditure(as % of GDP) in European Union in 2011 and the Expenditure(as % of GDP) in Moldova in 2013?
Provide a succinct answer. -26.86. What is the difference between the Expenditure(as % of GDP) of European Union in 2011 and the Expenditure(as % of GDP) of Solomon Islands in 2013?
Offer a terse response. -1.36. What is the difference between the Expenditure(as % of GDP) in European Union in 2011 and the Expenditure(as % of GDP) in Thailand in 2013?
Your answer should be very brief. -0.77. What is the difference between the Expenditure(as % of GDP) of Moldova in 2011 and the Expenditure(as % of GDP) of Solomon Islands in 2013?
Provide a succinct answer. 23.9. What is the difference between the Expenditure(as % of GDP) in Moldova in 2011 and the Expenditure(as % of GDP) in Thailand in 2013?
Offer a terse response. 24.49. What is the difference between the Expenditure(as % of GDP) of Solomon Islands in 2011 and the Expenditure(as % of GDP) of Thailand in 2013?
Your response must be concise. 0.56. What is the difference between the Expenditure(as % of GDP) in European Union in 2012 and the Expenditure(as % of GDP) in Moldova in 2013?
Your answer should be very brief. -26.84. What is the difference between the Expenditure(as % of GDP) in European Union in 2012 and the Expenditure(as % of GDP) in Solomon Islands in 2013?
Your response must be concise. -1.34. What is the difference between the Expenditure(as % of GDP) in European Union in 2012 and the Expenditure(as % of GDP) in Thailand in 2013?
Give a very brief answer. -0.74. What is the difference between the Expenditure(as % of GDP) in Moldova in 2012 and the Expenditure(as % of GDP) in Solomon Islands in 2013?
Offer a terse response. 25.32. What is the difference between the Expenditure(as % of GDP) in Moldova in 2012 and the Expenditure(as % of GDP) in Thailand in 2013?
Keep it short and to the point. 25.91. What is the difference between the Expenditure(as % of GDP) of Solomon Islands in 2012 and the Expenditure(as % of GDP) of Thailand in 2013?
Make the answer very short. 0.67. What is the average Expenditure(as % of GDP) in European Union per year?
Ensure brevity in your answer.  0.56. What is the average Expenditure(as % of GDP) in Moldova per year?
Keep it short and to the point. 28.18. What is the average Expenditure(as % of GDP) in Solomon Islands per year?
Keep it short and to the point. 2.05. What is the average Expenditure(as % of GDP) in Thailand per year?
Provide a short and direct response. 0.96. In the year 2006, what is the difference between the Expenditure(as % of GDP) in European Union and Expenditure(as % of GDP) in Moldova?
Keep it short and to the point. -34. In the year 2006, what is the difference between the Expenditure(as % of GDP) of European Union and Expenditure(as % of GDP) of Solomon Islands?
Offer a very short reply. -1.85. In the year 2006, what is the difference between the Expenditure(as % of GDP) of European Union and Expenditure(as % of GDP) of Thailand?
Keep it short and to the point. -0.1. In the year 2006, what is the difference between the Expenditure(as % of GDP) of Moldova and Expenditure(as % of GDP) of Solomon Islands?
Provide a short and direct response. 32.15. In the year 2006, what is the difference between the Expenditure(as % of GDP) of Moldova and Expenditure(as % of GDP) of Thailand?
Your response must be concise. 33.9. In the year 2006, what is the difference between the Expenditure(as % of GDP) of Solomon Islands and Expenditure(as % of GDP) of Thailand?
Your answer should be very brief. 1.75. In the year 2007, what is the difference between the Expenditure(as % of GDP) of European Union and Expenditure(as % of GDP) of Moldova?
Ensure brevity in your answer.  -33.37. In the year 2007, what is the difference between the Expenditure(as % of GDP) of European Union and Expenditure(as % of GDP) of Solomon Islands?
Provide a succinct answer. -1.93. In the year 2007, what is the difference between the Expenditure(as % of GDP) of European Union and Expenditure(as % of GDP) of Thailand?
Give a very brief answer. -0.1. In the year 2007, what is the difference between the Expenditure(as % of GDP) in Moldova and Expenditure(as % of GDP) in Solomon Islands?
Your answer should be compact. 31.44. In the year 2007, what is the difference between the Expenditure(as % of GDP) in Moldova and Expenditure(as % of GDP) in Thailand?
Your answer should be very brief. 33.26. In the year 2007, what is the difference between the Expenditure(as % of GDP) of Solomon Islands and Expenditure(as % of GDP) of Thailand?
Your response must be concise. 1.83. In the year 2008, what is the difference between the Expenditure(as % of GDP) of European Union and Expenditure(as % of GDP) of Moldova?
Ensure brevity in your answer.  -30.64. In the year 2008, what is the difference between the Expenditure(as % of GDP) of European Union and Expenditure(as % of GDP) of Solomon Islands?
Provide a short and direct response. -0.96. In the year 2008, what is the difference between the Expenditure(as % of GDP) of European Union and Expenditure(as % of GDP) of Thailand?
Keep it short and to the point. -0.11. In the year 2008, what is the difference between the Expenditure(as % of GDP) in Moldova and Expenditure(as % of GDP) in Solomon Islands?
Provide a short and direct response. 29.68. In the year 2008, what is the difference between the Expenditure(as % of GDP) of Moldova and Expenditure(as % of GDP) of Thailand?
Your answer should be very brief. 30.53. In the year 2008, what is the difference between the Expenditure(as % of GDP) in Solomon Islands and Expenditure(as % of GDP) in Thailand?
Provide a short and direct response. 0.85. In the year 2009, what is the difference between the Expenditure(as % of GDP) in European Union and Expenditure(as % of GDP) in Moldova?
Your response must be concise. -21.49. In the year 2009, what is the difference between the Expenditure(as % of GDP) in European Union and Expenditure(as % of GDP) in Solomon Islands?
Offer a terse response. -1.54. In the year 2009, what is the difference between the Expenditure(as % of GDP) of European Union and Expenditure(as % of GDP) of Thailand?
Your response must be concise. -0.44. In the year 2009, what is the difference between the Expenditure(as % of GDP) of Moldova and Expenditure(as % of GDP) of Solomon Islands?
Your answer should be compact. 19.94. In the year 2009, what is the difference between the Expenditure(as % of GDP) in Moldova and Expenditure(as % of GDP) in Thailand?
Your answer should be very brief. 21.05. In the year 2009, what is the difference between the Expenditure(as % of GDP) of Solomon Islands and Expenditure(as % of GDP) of Thailand?
Offer a very short reply. 1.11. In the year 2010, what is the difference between the Expenditure(as % of GDP) of European Union and Expenditure(as % of GDP) of Moldova?
Your response must be concise. -22.71. In the year 2010, what is the difference between the Expenditure(as % of GDP) in European Union and Expenditure(as % of GDP) in Solomon Islands?
Offer a very short reply. -1.58. In the year 2010, what is the difference between the Expenditure(as % of GDP) in European Union and Expenditure(as % of GDP) in Thailand?
Your answer should be compact. -0.5. In the year 2010, what is the difference between the Expenditure(as % of GDP) of Moldova and Expenditure(as % of GDP) of Solomon Islands?
Your answer should be very brief. 21.13. In the year 2010, what is the difference between the Expenditure(as % of GDP) in Moldova and Expenditure(as % of GDP) in Thailand?
Offer a very short reply. 22.2. In the year 2010, what is the difference between the Expenditure(as % of GDP) in Solomon Islands and Expenditure(as % of GDP) in Thailand?
Provide a succinct answer. 1.08. In the year 2011, what is the difference between the Expenditure(as % of GDP) of European Union and Expenditure(as % of GDP) of Moldova?
Your response must be concise. -25.26. In the year 2011, what is the difference between the Expenditure(as % of GDP) in European Union and Expenditure(as % of GDP) in Solomon Islands?
Offer a terse response. -1.32. In the year 2011, what is the difference between the Expenditure(as % of GDP) of European Union and Expenditure(as % of GDP) of Thailand?
Provide a short and direct response. -0.64. In the year 2011, what is the difference between the Expenditure(as % of GDP) of Moldova and Expenditure(as % of GDP) of Solomon Islands?
Give a very brief answer. 23.94. In the year 2011, what is the difference between the Expenditure(as % of GDP) in Moldova and Expenditure(as % of GDP) in Thailand?
Your answer should be very brief. 24.62. In the year 2011, what is the difference between the Expenditure(as % of GDP) of Solomon Islands and Expenditure(as % of GDP) of Thailand?
Keep it short and to the point. 0.68. In the year 2012, what is the difference between the Expenditure(as % of GDP) of European Union and Expenditure(as % of GDP) of Moldova?
Your response must be concise. -26.66. In the year 2012, what is the difference between the Expenditure(as % of GDP) in European Union and Expenditure(as % of GDP) in Solomon Islands?
Make the answer very short. -1.41. In the year 2012, what is the difference between the Expenditure(as % of GDP) in European Union and Expenditure(as % of GDP) in Thailand?
Provide a short and direct response. -0.57. In the year 2012, what is the difference between the Expenditure(as % of GDP) in Moldova and Expenditure(as % of GDP) in Solomon Islands?
Offer a terse response. 25.25. In the year 2012, what is the difference between the Expenditure(as % of GDP) of Moldova and Expenditure(as % of GDP) of Thailand?
Provide a succinct answer. 26.08. In the year 2012, what is the difference between the Expenditure(as % of GDP) in Solomon Islands and Expenditure(as % of GDP) in Thailand?
Your answer should be very brief. 0.84. In the year 2013, what is the difference between the Expenditure(as % of GDP) of European Union and Expenditure(as % of GDP) of Moldova?
Ensure brevity in your answer.  -26.81. In the year 2013, what is the difference between the Expenditure(as % of GDP) of European Union and Expenditure(as % of GDP) of Solomon Islands?
Offer a very short reply. -1.32. In the year 2013, what is the difference between the Expenditure(as % of GDP) in European Union and Expenditure(as % of GDP) in Thailand?
Provide a short and direct response. -0.72. In the year 2013, what is the difference between the Expenditure(as % of GDP) of Moldova and Expenditure(as % of GDP) of Solomon Islands?
Keep it short and to the point. 25.5. In the year 2013, what is the difference between the Expenditure(as % of GDP) in Moldova and Expenditure(as % of GDP) in Thailand?
Offer a very short reply. 26.09. In the year 2013, what is the difference between the Expenditure(as % of GDP) of Solomon Islands and Expenditure(as % of GDP) of Thailand?
Give a very brief answer. 0.59. What is the ratio of the Expenditure(as % of GDP) of European Union in 2006 to that in 2007?
Offer a terse response. 0.97. What is the ratio of the Expenditure(as % of GDP) of Moldova in 2006 to that in 2007?
Offer a terse response. 1.02. What is the ratio of the Expenditure(as % of GDP) in Solomon Islands in 2006 to that in 2007?
Offer a terse response. 0.96. What is the ratio of the Expenditure(as % of GDP) of Thailand in 2006 to that in 2007?
Your answer should be very brief. 0.97. What is the ratio of the Expenditure(as % of GDP) in European Union in 2006 to that in 2008?
Provide a short and direct response. 0.92. What is the ratio of the Expenditure(as % of GDP) in Moldova in 2006 to that in 2008?
Your answer should be compact. 1.11. What is the ratio of the Expenditure(as % of GDP) in Solomon Islands in 2006 to that in 2008?
Your answer should be very brief. 1.56. What is the ratio of the Expenditure(as % of GDP) in Thailand in 2006 to that in 2008?
Provide a short and direct response. 0.92. What is the ratio of the Expenditure(as % of GDP) of European Union in 2006 to that in 2009?
Provide a short and direct response. 0.92. What is the ratio of the Expenditure(as % of GDP) of Moldova in 2006 to that in 2009?
Make the answer very short. 1.57. What is the ratio of the Expenditure(as % of GDP) of Solomon Islands in 2006 to that in 2009?
Give a very brief answer. 1.12. What is the ratio of the Expenditure(as % of GDP) in Thailand in 2006 to that in 2009?
Offer a very short reply. 0.61. What is the ratio of the Expenditure(as % of GDP) in European Union in 2006 to that in 2010?
Provide a succinct answer. 0.92. What is the ratio of the Expenditure(as % of GDP) of Moldova in 2006 to that in 2010?
Ensure brevity in your answer.  1.48. What is the ratio of the Expenditure(as % of GDP) in Solomon Islands in 2006 to that in 2010?
Your response must be concise. 1.11. What is the ratio of the Expenditure(as % of GDP) of Thailand in 2006 to that in 2010?
Give a very brief answer. 0.57. What is the ratio of the Expenditure(as % of GDP) in European Union in 2006 to that in 2011?
Provide a short and direct response. 0.86. What is the ratio of the Expenditure(as % of GDP) in Moldova in 2006 to that in 2011?
Keep it short and to the point. 1.33. What is the ratio of the Expenditure(as % of GDP) of Solomon Islands in 2006 to that in 2011?
Provide a short and direct response. 1.23. What is the ratio of the Expenditure(as % of GDP) in Thailand in 2006 to that in 2011?
Ensure brevity in your answer.  0.49. What is the ratio of the Expenditure(as % of GDP) in European Union in 2006 to that in 2012?
Ensure brevity in your answer.  0.82. What is the ratio of the Expenditure(as % of GDP) of Moldova in 2006 to that in 2012?
Your response must be concise. 1.27. What is the ratio of the Expenditure(as % of GDP) in Solomon Islands in 2006 to that in 2012?
Your answer should be compact. 1.16. What is the ratio of the Expenditure(as % of GDP) in Thailand in 2006 to that in 2012?
Offer a very short reply. 0.51. What is the ratio of the Expenditure(as % of GDP) in European Union in 2006 to that in 2013?
Ensure brevity in your answer.  0.79. What is the ratio of the Expenditure(as % of GDP) of Moldova in 2006 to that in 2013?
Your response must be concise. 1.26. What is the ratio of the Expenditure(as % of GDP) in Solomon Islands in 2006 to that in 2013?
Provide a succinct answer. 1.21. What is the ratio of the Expenditure(as % of GDP) in Thailand in 2006 to that in 2013?
Keep it short and to the point. 0.44. What is the ratio of the Expenditure(as % of GDP) of European Union in 2007 to that in 2008?
Provide a succinct answer. 0.95. What is the ratio of the Expenditure(as % of GDP) in Moldova in 2007 to that in 2008?
Offer a very short reply. 1.09. What is the ratio of the Expenditure(as % of GDP) in Solomon Islands in 2007 to that in 2008?
Give a very brief answer. 1.63. What is the ratio of the Expenditure(as % of GDP) in Thailand in 2007 to that in 2008?
Make the answer very short. 0.95. What is the ratio of the Expenditure(as % of GDP) in European Union in 2007 to that in 2009?
Provide a succinct answer. 0.94. What is the ratio of the Expenditure(as % of GDP) in Moldova in 2007 to that in 2009?
Offer a very short reply. 1.54. What is the ratio of the Expenditure(as % of GDP) of Solomon Islands in 2007 to that in 2009?
Give a very brief answer. 1.17. What is the ratio of the Expenditure(as % of GDP) in Thailand in 2007 to that in 2009?
Your response must be concise. 0.63. What is the ratio of the Expenditure(as % of GDP) of European Union in 2007 to that in 2010?
Provide a short and direct response. 0.95. What is the ratio of the Expenditure(as % of GDP) of Moldova in 2007 to that in 2010?
Give a very brief answer. 1.46. What is the ratio of the Expenditure(as % of GDP) of Solomon Islands in 2007 to that in 2010?
Your answer should be compact. 1.15. What is the ratio of the Expenditure(as % of GDP) of Thailand in 2007 to that in 2010?
Provide a short and direct response. 0.59. What is the ratio of the Expenditure(as % of GDP) of European Union in 2007 to that in 2011?
Keep it short and to the point. 0.88. What is the ratio of the Expenditure(as % of GDP) in Moldova in 2007 to that in 2011?
Your response must be concise. 1.31. What is the ratio of the Expenditure(as % of GDP) in Solomon Islands in 2007 to that in 2011?
Provide a short and direct response. 1.28. What is the ratio of the Expenditure(as % of GDP) of Thailand in 2007 to that in 2011?
Provide a short and direct response. 0.51. What is the ratio of the Expenditure(as % of GDP) in European Union in 2007 to that in 2012?
Ensure brevity in your answer.  0.85. What is the ratio of the Expenditure(as % of GDP) in Moldova in 2007 to that in 2012?
Make the answer very short. 1.24. What is the ratio of the Expenditure(as % of GDP) of Solomon Islands in 2007 to that in 2012?
Offer a very short reply. 1.21. What is the ratio of the Expenditure(as % of GDP) of Thailand in 2007 to that in 2012?
Keep it short and to the point. 0.52. What is the ratio of the Expenditure(as % of GDP) of European Union in 2007 to that in 2013?
Your answer should be compact. 0.82. What is the ratio of the Expenditure(as % of GDP) in Moldova in 2007 to that in 2013?
Your answer should be very brief. 1.23. What is the ratio of the Expenditure(as % of GDP) of Solomon Islands in 2007 to that in 2013?
Provide a short and direct response. 1.26. What is the ratio of the Expenditure(as % of GDP) in Thailand in 2007 to that in 2013?
Offer a terse response. 0.46. What is the ratio of the Expenditure(as % of GDP) of European Union in 2008 to that in 2009?
Offer a very short reply. 0.99. What is the ratio of the Expenditure(as % of GDP) of Moldova in 2008 to that in 2009?
Provide a succinct answer. 1.42. What is the ratio of the Expenditure(as % of GDP) of Solomon Islands in 2008 to that in 2009?
Make the answer very short. 0.72. What is the ratio of the Expenditure(as % of GDP) in Thailand in 2008 to that in 2009?
Offer a very short reply. 0.66. What is the ratio of the Expenditure(as % of GDP) in European Union in 2008 to that in 2010?
Ensure brevity in your answer.  1. What is the ratio of the Expenditure(as % of GDP) of Moldova in 2008 to that in 2010?
Ensure brevity in your answer.  1.34. What is the ratio of the Expenditure(as % of GDP) of Solomon Islands in 2008 to that in 2010?
Offer a very short reply. 0.71. What is the ratio of the Expenditure(as % of GDP) of Thailand in 2008 to that in 2010?
Offer a very short reply. 0.62. What is the ratio of the Expenditure(as % of GDP) in European Union in 2008 to that in 2011?
Keep it short and to the point. 0.93. What is the ratio of the Expenditure(as % of GDP) of Moldova in 2008 to that in 2011?
Your answer should be compact. 1.21. What is the ratio of the Expenditure(as % of GDP) of Solomon Islands in 2008 to that in 2011?
Ensure brevity in your answer.  0.79. What is the ratio of the Expenditure(as % of GDP) in Thailand in 2008 to that in 2011?
Offer a terse response. 0.53. What is the ratio of the Expenditure(as % of GDP) of European Union in 2008 to that in 2012?
Offer a very short reply. 0.89. What is the ratio of the Expenditure(as % of GDP) of Moldova in 2008 to that in 2012?
Offer a very short reply. 1.14. What is the ratio of the Expenditure(as % of GDP) in Solomon Islands in 2008 to that in 2012?
Your response must be concise. 0.74. What is the ratio of the Expenditure(as % of GDP) in Thailand in 2008 to that in 2012?
Keep it short and to the point. 0.55. What is the ratio of the Expenditure(as % of GDP) of European Union in 2008 to that in 2013?
Provide a short and direct response. 0.86. What is the ratio of the Expenditure(as % of GDP) of Moldova in 2008 to that in 2013?
Your answer should be very brief. 1.14. What is the ratio of the Expenditure(as % of GDP) in Solomon Islands in 2008 to that in 2013?
Offer a terse response. 0.77. What is the ratio of the Expenditure(as % of GDP) in Thailand in 2008 to that in 2013?
Make the answer very short. 0.48. What is the ratio of the Expenditure(as % of GDP) in European Union in 2009 to that in 2010?
Your answer should be very brief. 1. What is the ratio of the Expenditure(as % of GDP) of Moldova in 2009 to that in 2010?
Ensure brevity in your answer.  0.95. What is the ratio of the Expenditure(as % of GDP) in Solomon Islands in 2009 to that in 2010?
Provide a short and direct response. 0.98. What is the ratio of the Expenditure(as % of GDP) in Thailand in 2009 to that in 2010?
Offer a terse response. 0.94. What is the ratio of the Expenditure(as % of GDP) of European Union in 2009 to that in 2011?
Provide a short and direct response. 0.94. What is the ratio of the Expenditure(as % of GDP) of Moldova in 2009 to that in 2011?
Make the answer very short. 0.85. What is the ratio of the Expenditure(as % of GDP) in Solomon Islands in 2009 to that in 2011?
Offer a terse response. 1.1. What is the ratio of the Expenditure(as % of GDP) in Thailand in 2009 to that in 2011?
Make the answer very short. 0.8. What is the ratio of the Expenditure(as % of GDP) in European Union in 2009 to that in 2012?
Your answer should be very brief. 0.9. What is the ratio of the Expenditure(as % of GDP) of Moldova in 2009 to that in 2012?
Give a very brief answer. 0.81. What is the ratio of the Expenditure(as % of GDP) of Solomon Islands in 2009 to that in 2012?
Make the answer very short. 1.04. What is the ratio of the Expenditure(as % of GDP) of Thailand in 2009 to that in 2012?
Keep it short and to the point. 0.83. What is the ratio of the Expenditure(as % of GDP) in European Union in 2009 to that in 2013?
Provide a short and direct response. 0.87. What is the ratio of the Expenditure(as % of GDP) of Moldova in 2009 to that in 2013?
Provide a succinct answer. 0.8. What is the ratio of the Expenditure(as % of GDP) of Solomon Islands in 2009 to that in 2013?
Make the answer very short. 1.07. What is the ratio of the Expenditure(as % of GDP) in Thailand in 2009 to that in 2013?
Provide a succinct answer. 0.73. What is the ratio of the Expenditure(as % of GDP) of European Union in 2010 to that in 2011?
Give a very brief answer. 0.93. What is the ratio of the Expenditure(as % of GDP) of Moldova in 2010 to that in 2011?
Ensure brevity in your answer.  0.9. What is the ratio of the Expenditure(as % of GDP) in Solomon Islands in 2010 to that in 2011?
Offer a terse response. 1.11. What is the ratio of the Expenditure(as % of GDP) of Thailand in 2010 to that in 2011?
Your answer should be very brief. 0.85. What is the ratio of the Expenditure(as % of GDP) in European Union in 2010 to that in 2012?
Make the answer very short. 0.89. What is the ratio of the Expenditure(as % of GDP) of Moldova in 2010 to that in 2012?
Offer a terse response. 0.85. What is the ratio of the Expenditure(as % of GDP) in Solomon Islands in 2010 to that in 2012?
Provide a succinct answer. 1.05. What is the ratio of the Expenditure(as % of GDP) in Thailand in 2010 to that in 2012?
Ensure brevity in your answer.  0.89. What is the ratio of the Expenditure(as % of GDP) in European Union in 2010 to that in 2013?
Provide a succinct answer. 0.86. What is the ratio of the Expenditure(as % of GDP) in Moldova in 2010 to that in 2013?
Provide a short and direct response. 0.85. What is the ratio of the Expenditure(as % of GDP) of Solomon Islands in 2010 to that in 2013?
Provide a short and direct response. 1.09. What is the ratio of the Expenditure(as % of GDP) of Thailand in 2010 to that in 2013?
Give a very brief answer. 0.78. What is the ratio of the Expenditure(as % of GDP) in European Union in 2011 to that in 2012?
Offer a very short reply. 0.96. What is the ratio of the Expenditure(as % of GDP) in Moldova in 2011 to that in 2012?
Give a very brief answer. 0.95. What is the ratio of the Expenditure(as % of GDP) of Solomon Islands in 2011 to that in 2012?
Keep it short and to the point. 0.94. What is the ratio of the Expenditure(as % of GDP) of Thailand in 2011 to that in 2012?
Your answer should be compact. 1.04. What is the ratio of the Expenditure(as % of GDP) of European Union in 2011 to that in 2013?
Provide a succinct answer. 0.93. What is the ratio of the Expenditure(as % of GDP) in Moldova in 2011 to that in 2013?
Ensure brevity in your answer.  0.94. What is the ratio of the Expenditure(as % of GDP) of Solomon Islands in 2011 to that in 2013?
Give a very brief answer. 0.98. What is the ratio of the Expenditure(as % of GDP) of Thailand in 2011 to that in 2013?
Offer a very short reply. 0.91. What is the ratio of the Expenditure(as % of GDP) of European Union in 2012 to that in 2013?
Provide a short and direct response. 0.97. What is the ratio of the Expenditure(as % of GDP) of Moldova in 2012 to that in 2013?
Your response must be concise. 0.99. What is the ratio of the Expenditure(as % of GDP) in Solomon Islands in 2012 to that in 2013?
Provide a short and direct response. 1.04. What is the ratio of the Expenditure(as % of GDP) in Thailand in 2012 to that in 2013?
Your answer should be very brief. 0.88. What is the difference between the highest and the second highest Expenditure(as % of GDP) of European Union?
Offer a terse response. 0.02. What is the difference between the highest and the second highest Expenditure(as % of GDP) in Moldova?
Provide a succinct answer. 0.62. What is the difference between the highest and the second highest Expenditure(as % of GDP) of Solomon Islands?
Ensure brevity in your answer.  0.1. What is the difference between the highest and the second highest Expenditure(as % of GDP) of Thailand?
Provide a succinct answer. 0.13. What is the difference between the highest and the lowest Expenditure(as % of GDP) of European Union?
Your answer should be compact. 0.13. What is the difference between the highest and the lowest Expenditure(as % of GDP) in Moldova?
Your response must be concise. 12.46. What is the difference between the highest and the lowest Expenditure(as % of GDP) in Solomon Islands?
Ensure brevity in your answer.  0.95. What is the difference between the highest and the lowest Expenditure(as % of GDP) of Thailand?
Your response must be concise. 0.75. 